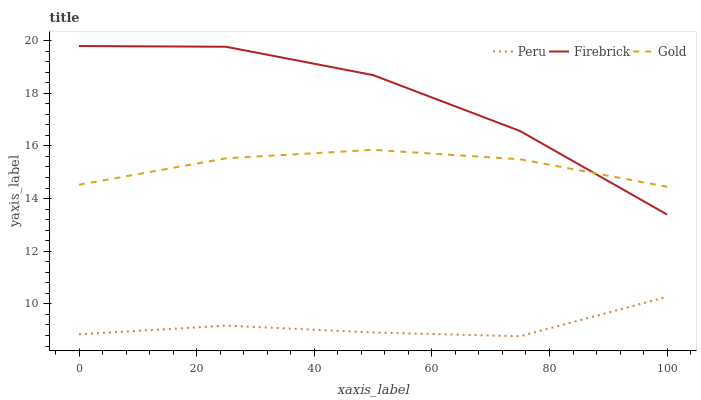Does Peru have the minimum area under the curve?
Answer yes or no. Yes. Does Firebrick have the maximum area under the curve?
Answer yes or no. Yes. Does Gold have the minimum area under the curve?
Answer yes or no. No. Does Gold have the maximum area under the curve?
Answer yes or no. No. Is Gold the smoothest?
Answer yes or no. Yes. Is Firebrick the roughest?
Answer yes or no. Yes. Is Peru the smoothest?
Answer yes or no. No. Is Peru the roughest?
Answer yes or no. No. Does Gold have the lowest value?
Answer yes or no. No. Does Gold have the highest value?
Answer yes or no. No. Is Peru less than Gold?
Answer yes or no. Yes. Is Gold greater than Peru?
Answer yes or no. Yes. Does Peru intersect Gold?
Answer yes or no. No. 